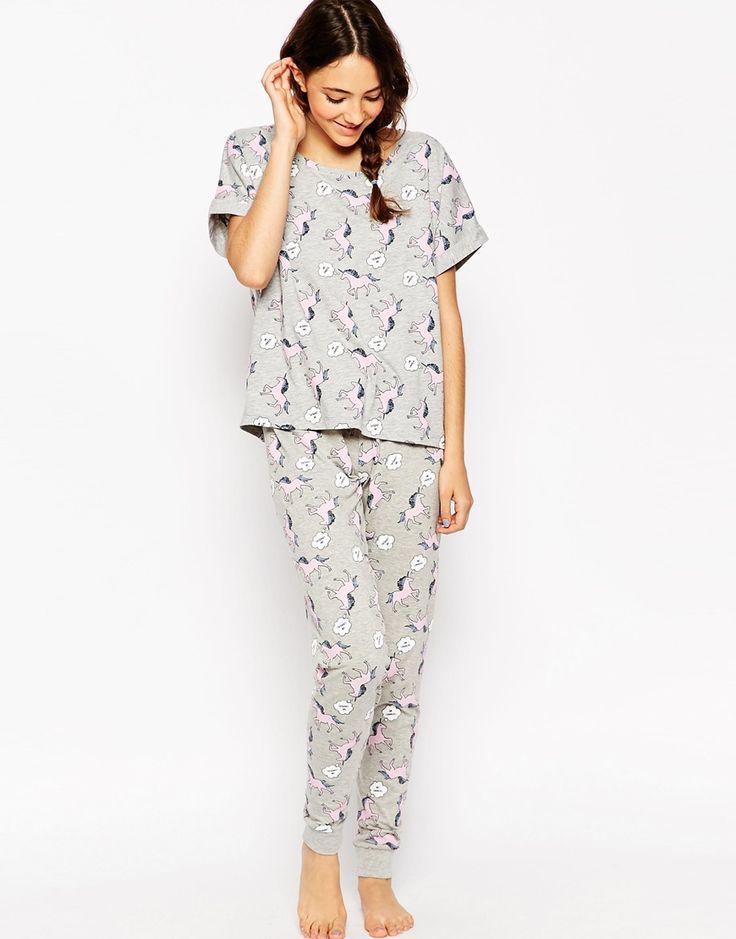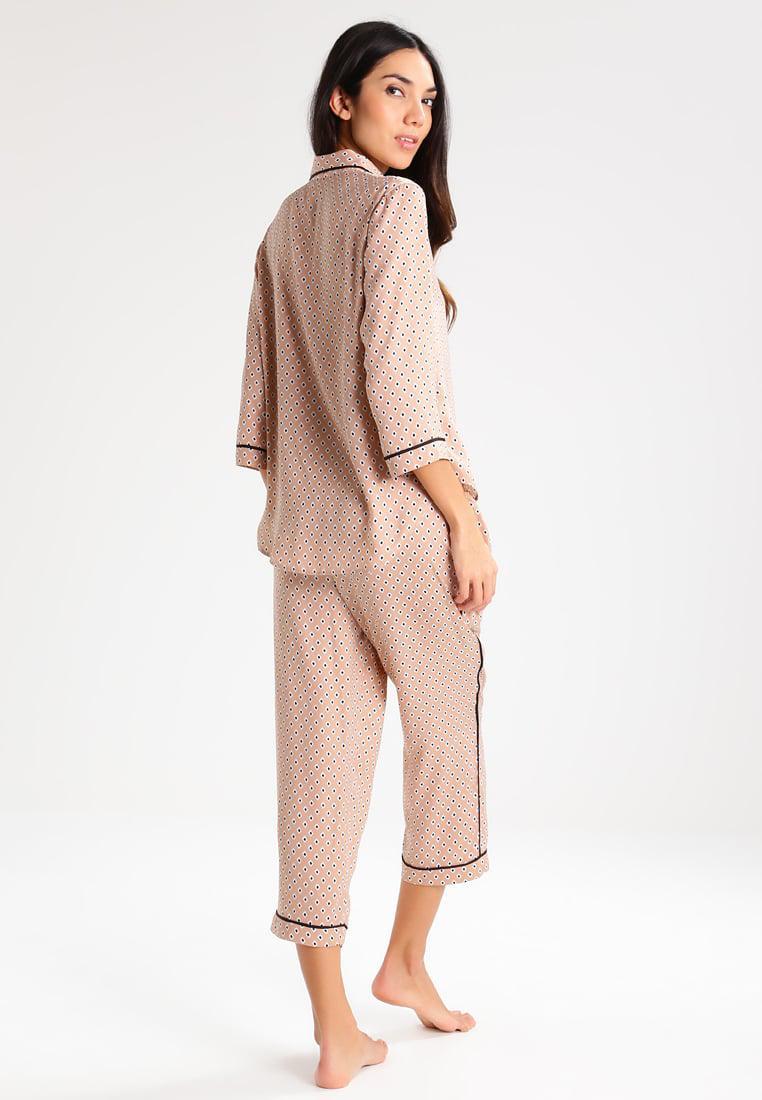The first image is the image on the left, the second image is the image on the right. Considering the images on both sides, is "In one image, a woman is wearing purple pajamas" valid? Answer yes or no. No. 